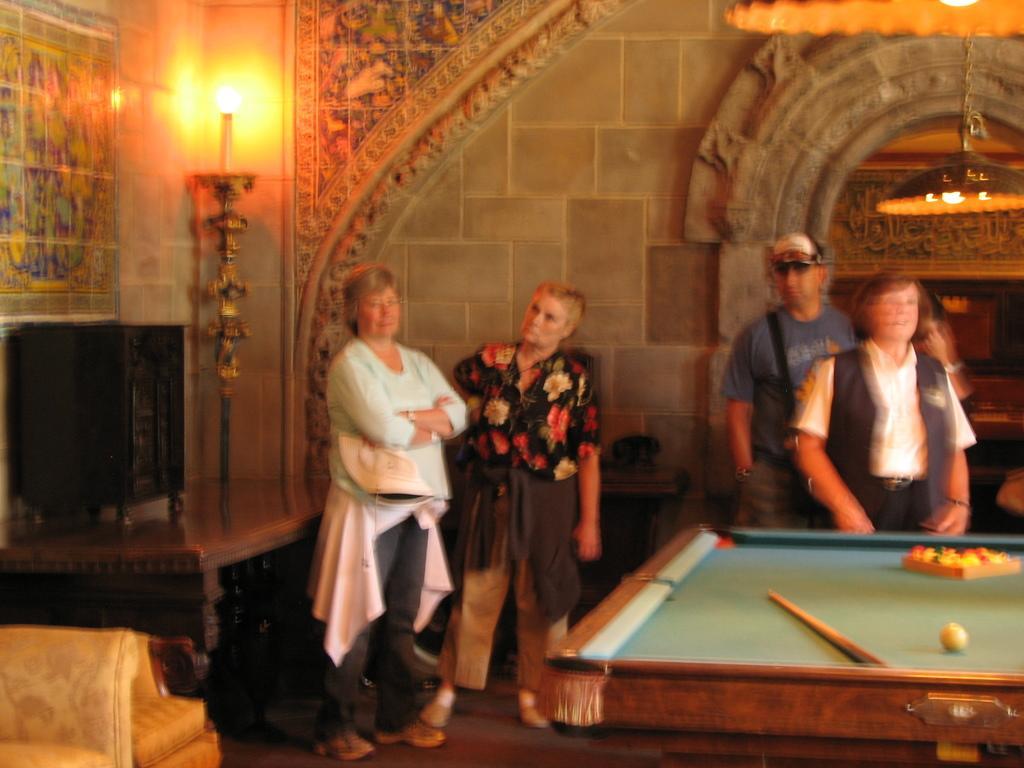Could you give a brief overview of what you see in this image? on the right there is a pool board. behind it 4 people are standing. at the left corner there is a candle. 